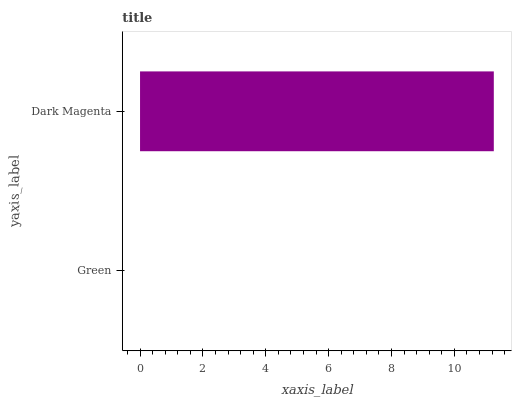Is Green the minimum?
Answer yes or no. Yes. Is Dark Magenta the maximum?
Answer yes or no. Yes. Is Dark Magenta the minimum?
Answer yes or no. No. Is Dark Magenta greater than Green?
Answer yes or no. Yes. Is Green less than Dark Magenta?
Answer yes or no. Yes. Is Green greater than Dark Magenta?
Answer yes or no. No. Is Dark Magenta less than Green?
Answer yes or no. No. Is Dark Magenta the high median?
Answer yes or no. Yes. Is Green the low median?
Answer yes or no. Yes. Is Green the high median?
Answer yes or no. No. Is Dark Magenta the low median?
Answer yes or no. No. 